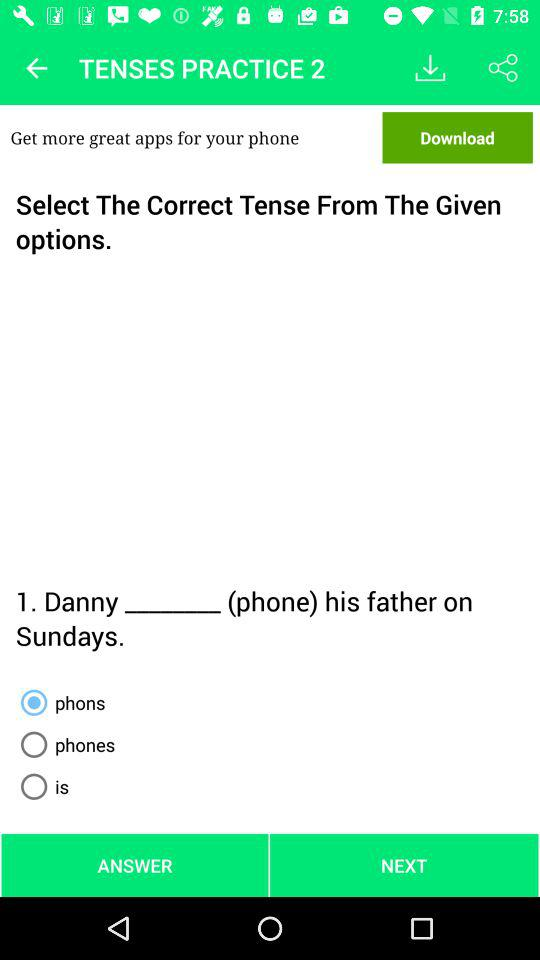Which option is selected? The selected option is "phons". 